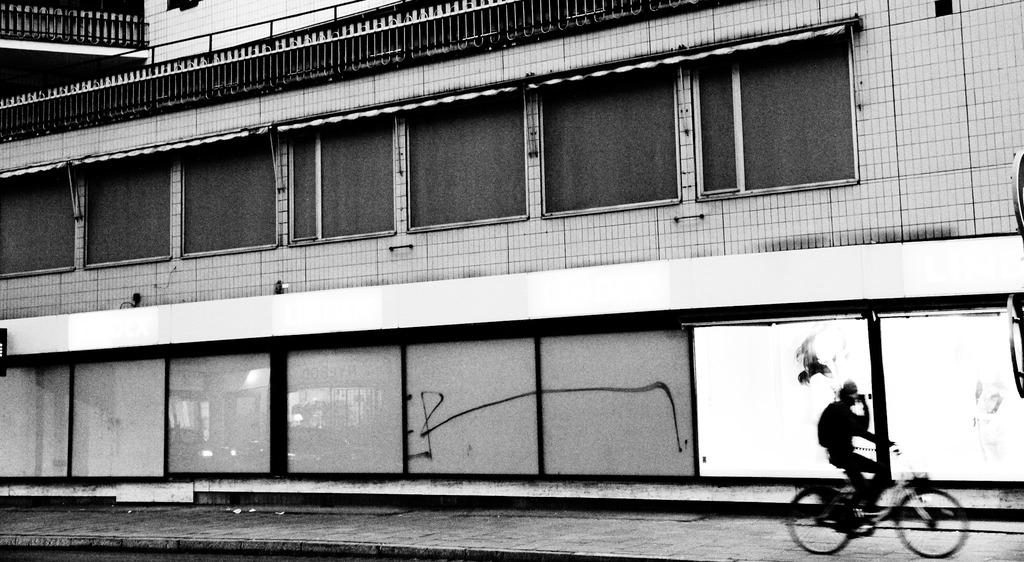What is on the ground in the image? There is a bicycle on the ground in the image. Who is on the bicycle? A person is on the bicycle. What can be seen in the distance in the image? There is a building in the background of the image. What else is present in the background of the image? Railings are present in the background of the image, along with other objects. How many times does the person on the bicycle kick the pocket in the image? There is no mention of a pocket or kicking in the image; the person is simply riding the bicycle. 